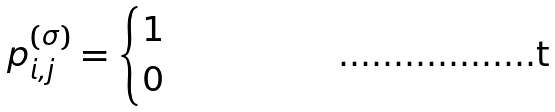Convert formula to latex. <formula><loc_0><loc_0><loc_500><loc_500>p _ { i , j } ^ { ( \sigma ) } = \begin{cases} 1 & \\ 0 & \end{cases}</formula> 